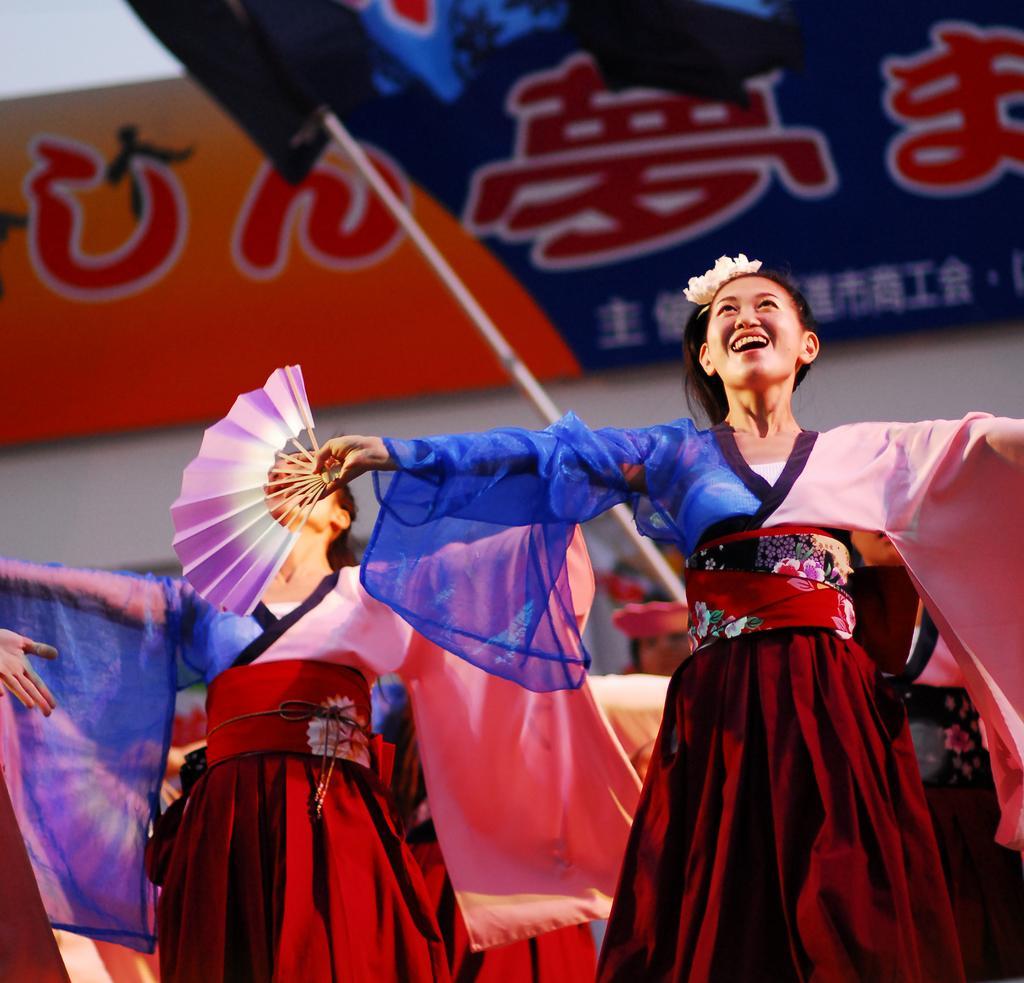How would you summarize this image in a sentence or two? In this image we can see groups of women wearing costumes. One woman is holding a hand fan in her hand. In the background, we can see a tent and a sign board with some text. 